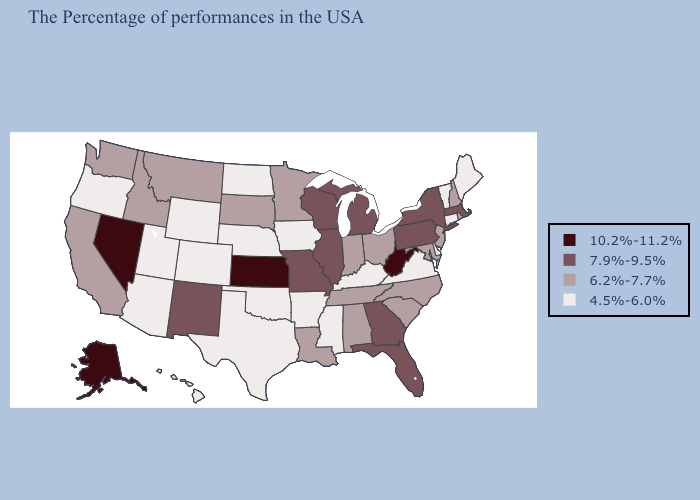What is the value of Alaska?
Concise answer only. 10.2%-11.2%. Among the states that border Nebraska , does Iowa have the highest value?
Answer briefly. No. Name the states that have a value in the range 10.2%-11.2%?
Quick response, please. West Virginia, Kansas, Nevada, Alaska. What is the lowest value in the MidWest?
Quick response, please. 4.5%-6.0%. What is the highest value in the USA?
Concise answer only. 10.2%-11.2%. Name the states that have a value in the range 10.2%-11.2%?
Keep it brief. West Virginia, Kansas, Nevada, Alaska. Does Wyoming have a lower value than Illinois?
Concise answer only. Yes. What is the value of Illinois?
Keep it brief. 7.9%-9.5%. What is the lowest value in states that border Wisconsin?
Quick response, please. 4.5%-6.0%. Name the states that have a value in the range 4.5%-6.0%?
Answer briefly. Maine, Vermont, Connecticut, Delaware, Virginia, Kentucky, Mississippi, Arkansas, Iowa, Nebraska, Oklahoma, Texas, North Dakota, Wyoming, Colorado, Utah, Arizona, Oregon, Hawaii. What is the lowest value in states that border Idaho?
Give a very brief answer. 4.5%-6.0%. What is the lowest value in the USA?
Short answer required. 4.5%-6.0%. What is the lowest value in the USA?
Give a very brief answer. 4.5%-6.0%. Name the states that have a value in the range 10.2%-11.2%?
Write a very short answer. West Virginia, Kansas, Nevada, Alaska. Name the states that have a value in the range 4.5%-6.0%?
Write a very short answer. Maine, Vermont, Connecticut, Delaware, Virginia, Kentucky, Mississippi, Arkansas, Iowa, Nebraska, Oklahoma, Texas, North Dakota, Wyoming, Colorado, Utah, Arizona, Oregon, Hawaii. 